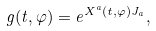<formula> <loc_0><loc_0><loc_500><loc_500>g ( t , \varphi ) = e ^ { X ^ { a } ( t , \varphi ) J _ { a } } ,</formula> 